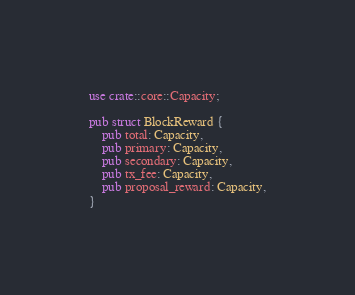Convert code to text. <code><loc_0><loc_0><loc_500><loc_500><_Rust_>use crate::core::Capacity;

pub struct BlockReward {
    pub total: Capacity,
    pub primary: Capacity,
    pub secondary: Capacity,
    pub tx_fee: Capacity,
    pub proposal_reward: Capacity,
}
</code> 